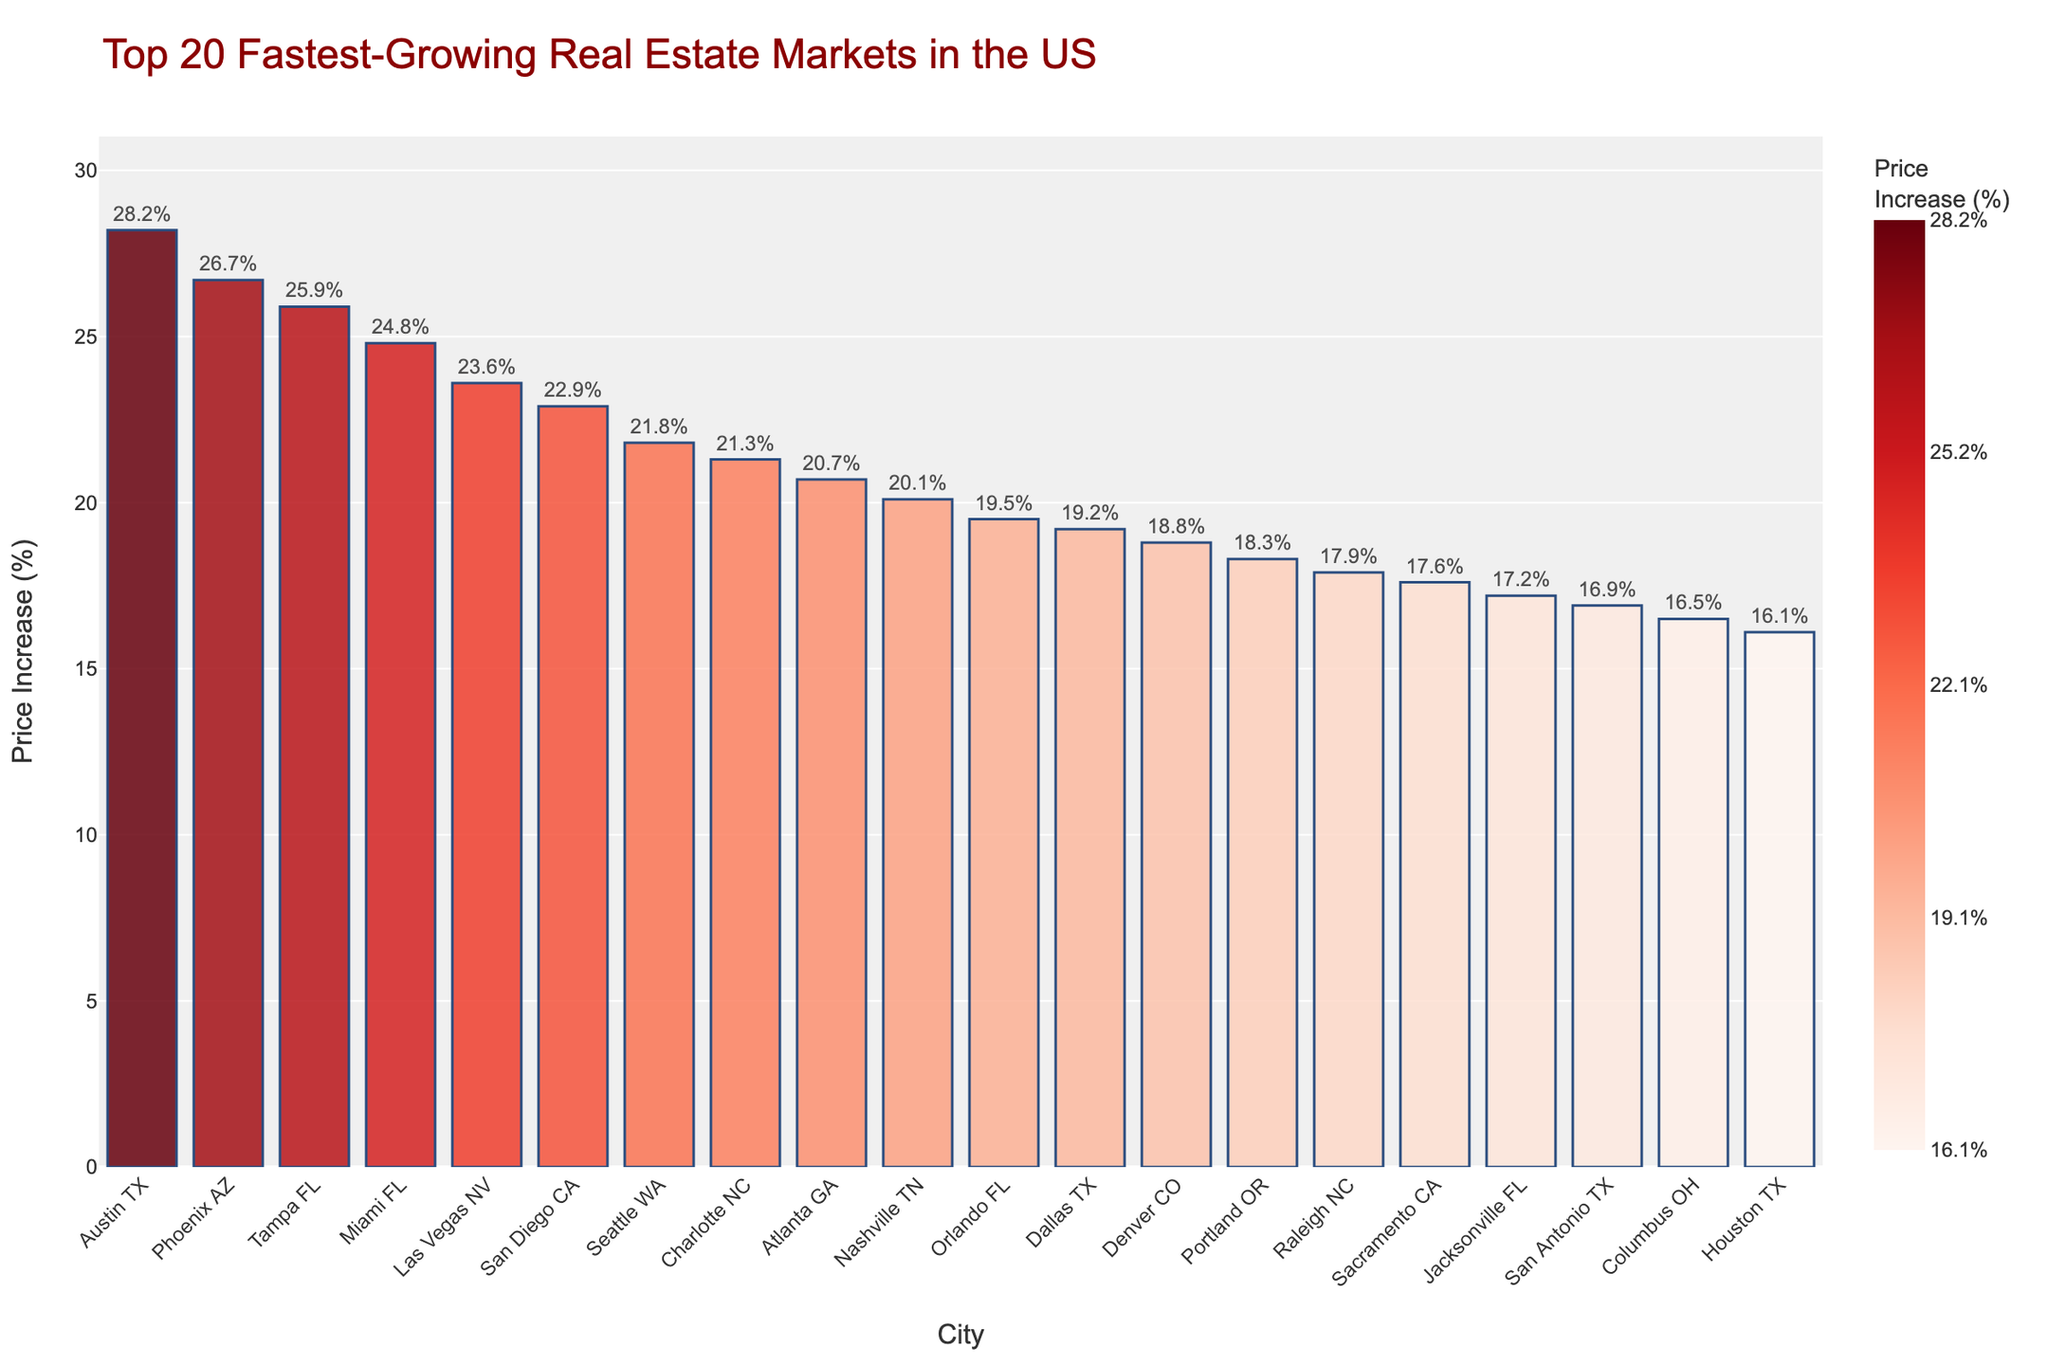What's the city with the highest price increase percentage? The bar for Austin, TX is the tallest on the chart, indicating it has the highest percentage increase.
Answer: Austin, TX Which city has a greater price increase percentage: Seattle, WA or Dallas, TX? Compare the heights of the bars for Seattle, WA and Dallas, TX. The bar for Seattle, WA is taller.
Answer: Seattle, WA What is the combined price increase percentage for the cities in Florida ranked in the top 10? Identify Tampa (25.9%), Miami (24.8%), and then add their percentages together: 25.9 + 24.8 = 50.7.
Answer: 50.7 How does the price increase percentage of Las Vegas, NV compare to Orlando, FL? The height of the bar for Las Vegas, NV is greater than that for Orlando, FL.
Answer: Greater What's the approximate difference in price increase percentage between the top-ranked and bottom-ranked cities? Take the percentage increase for Austin, TX (28.2%) and Houston, TX (16.1%), then subtract the latter from the former: 28.2 - 16.1 = 12.1.
Answer: 12.1 What is the color gradient indicating about the price increase percentages? The color gradient from lighter to darker red shows the range of price increase percentages, with darker shades representing higher percentages.
Answer: Darker red means higher increases Which city has the closest price increase percentage to the overall median of the top 20 cities listed? Arrange the percentages to find the median. Between the 10th and 11th value: Nashville (20.1%) and Orlando (19.5%), the median is around 19.8. Sacramento at 17.6% is closest.
Answer: Sacramento, CA If you were to visit cities with at least a 25% increase, which ones would you choose? Identify the cities where the percentage is 25% or greater: Austin, TX (28.2%), Phoenix, AZ (26.7%), and Tampa, FL (25.9%).
Answer: Austin, Phoenix, Tampa Which states have multiple cities in the top 20, and what are their combined price increase percentages? Identify states with multiple entries, calculate each state's combined percentages:
- TX: Austin (28.2) + Dallas (19.2) + San Antonio (16.9) + Houston (16.1) = 80.4
- FL: Tampa (25.9) + Miami (24.8) + Orlando (19.5) + Jacksonville (17.2) = 87.4
- NC: Charlotte (21.3) + Raleigh (17.9) = 39.2
- CA: San Diego (22.9) + Sacramento (17.6) = 40.5
Answer: TX: 80.4, FL: 87.4, NC: 39.2, CA: 40.5 